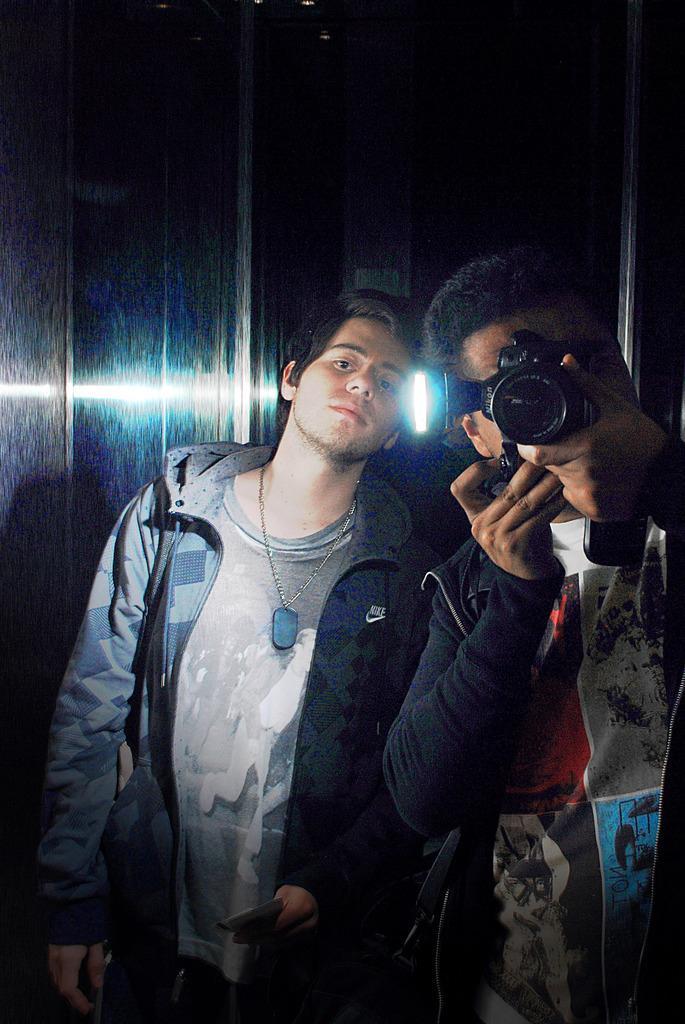Describe this image in one or two sentences. In this image there are two men standing. One man is holding a camera and taking pictures. And the other man is wearing a jerkin and standing. 